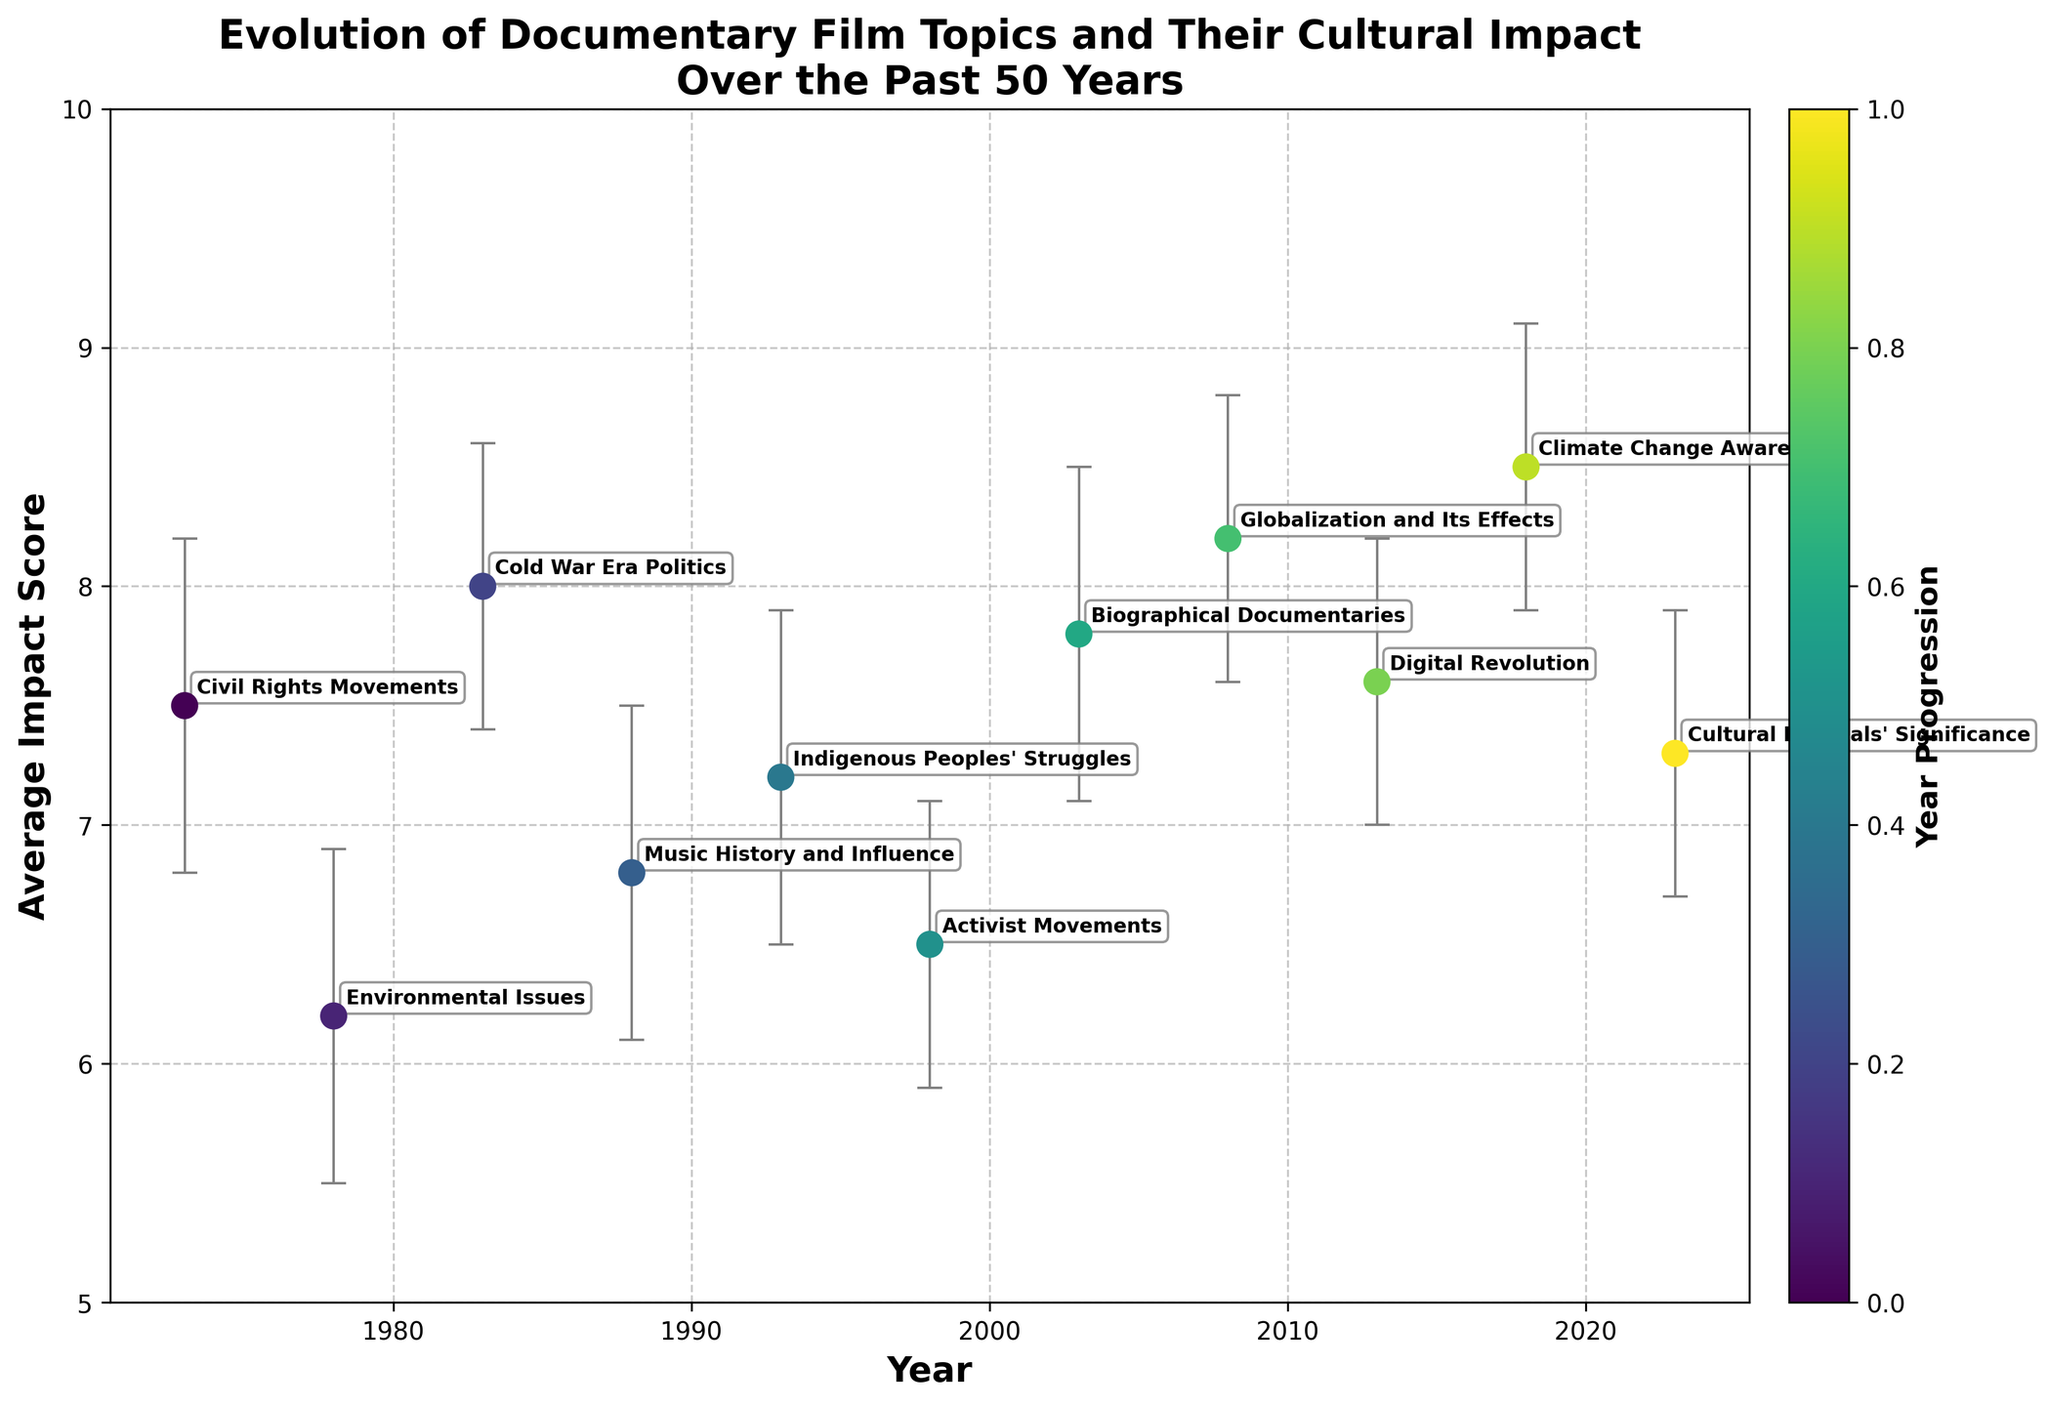What's the title of the figure? The title is displayed at the top of the plot. It reads: 'Evolution of Documentary Film Topics and Their Cultural Impact Over the Past 50 Years'
Answer: Evolution of Documentary Film Topics and Their Cultural Impact Over the Past 50 Years What is the purpose of the colors used in the scatter plot? The colors represent the year progression of the topics over the 50-year span, with a color bar on the right for reference.
Answer: Year progression Which year and topic have the highest average impact score? By examining the points and labels on the graph, we can see that the highest average impact score is in 2018 for "Climate Change Awareness" with a score of 8.5
Answer: 2018, Climate Change Awareness What is the trend in the average impact score from 2003 to 2018? Observing the points and their years, the average impact scores increase progressively from 7.8 in 2003, to 8.2 in 2008, and finally to 8.5 in 2018. The trend shows a consistent increase in this period.
Answer: Consistent increase How does the error bar for "Globalization and Its Effects" (2008) compare to the other topics? To compare, we observe that the error bar for "Globalization and Its Effects" (8.2) is fairly average in length compared to others. It is neither the shortest nor the longest error bar.
Answer: Average length Which two topics have the closest average impact scores in the dataset, and what are those scores? By analyzing the scatter plot, "Civil Rights Movements" (7.5) in 1973 and "Digital Revolution" (7.6) in 2013 have the closest average impact scores, with a difference of just 0.1.
Answer: Civil Rights Movements (7.5) and Digital Revolution (7.6) What’s the average impact score of the topics between 1993 and 2003 inclusive? The average impact scores for 1993, 1998, and 2003 are 7.2, 6.5, and 7.8 respectively. Adding them gives 21.5, and dividing by 3 gives an average of 21.5 / 3 = 7.17
Answer: 7.17 Which topic has the broadest error margin, and what is the span? By comparing the lengths of the error bars, "Climate Change Awareness" (2018) has the broadest error margin. The lower bound is 7.9 and the upper bound is 9.1, giving a span of 9.1 - 7.9 = 1.2
Answer: Climate Change Awareness, 1.2 